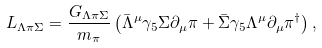Convert formula to latex. <formula><loc_0><loc_0><loc_500><loc_500>L _ { \Lambda \pi \Sigma } = \frac { G _ { \Lambda \pi \Sigma } } { m _ { \pi } } \left ( \bar { \Lambda } ^ { \mu } \gamma _ { 5 } \Sigma \partial _ { \mu } \pi + \bar { \Sigma } \gamma _ { 5 } \Lambda ^ { \mu } \partial _ { \mu } \pi ^ { \dag } \right ) ,</formula> 